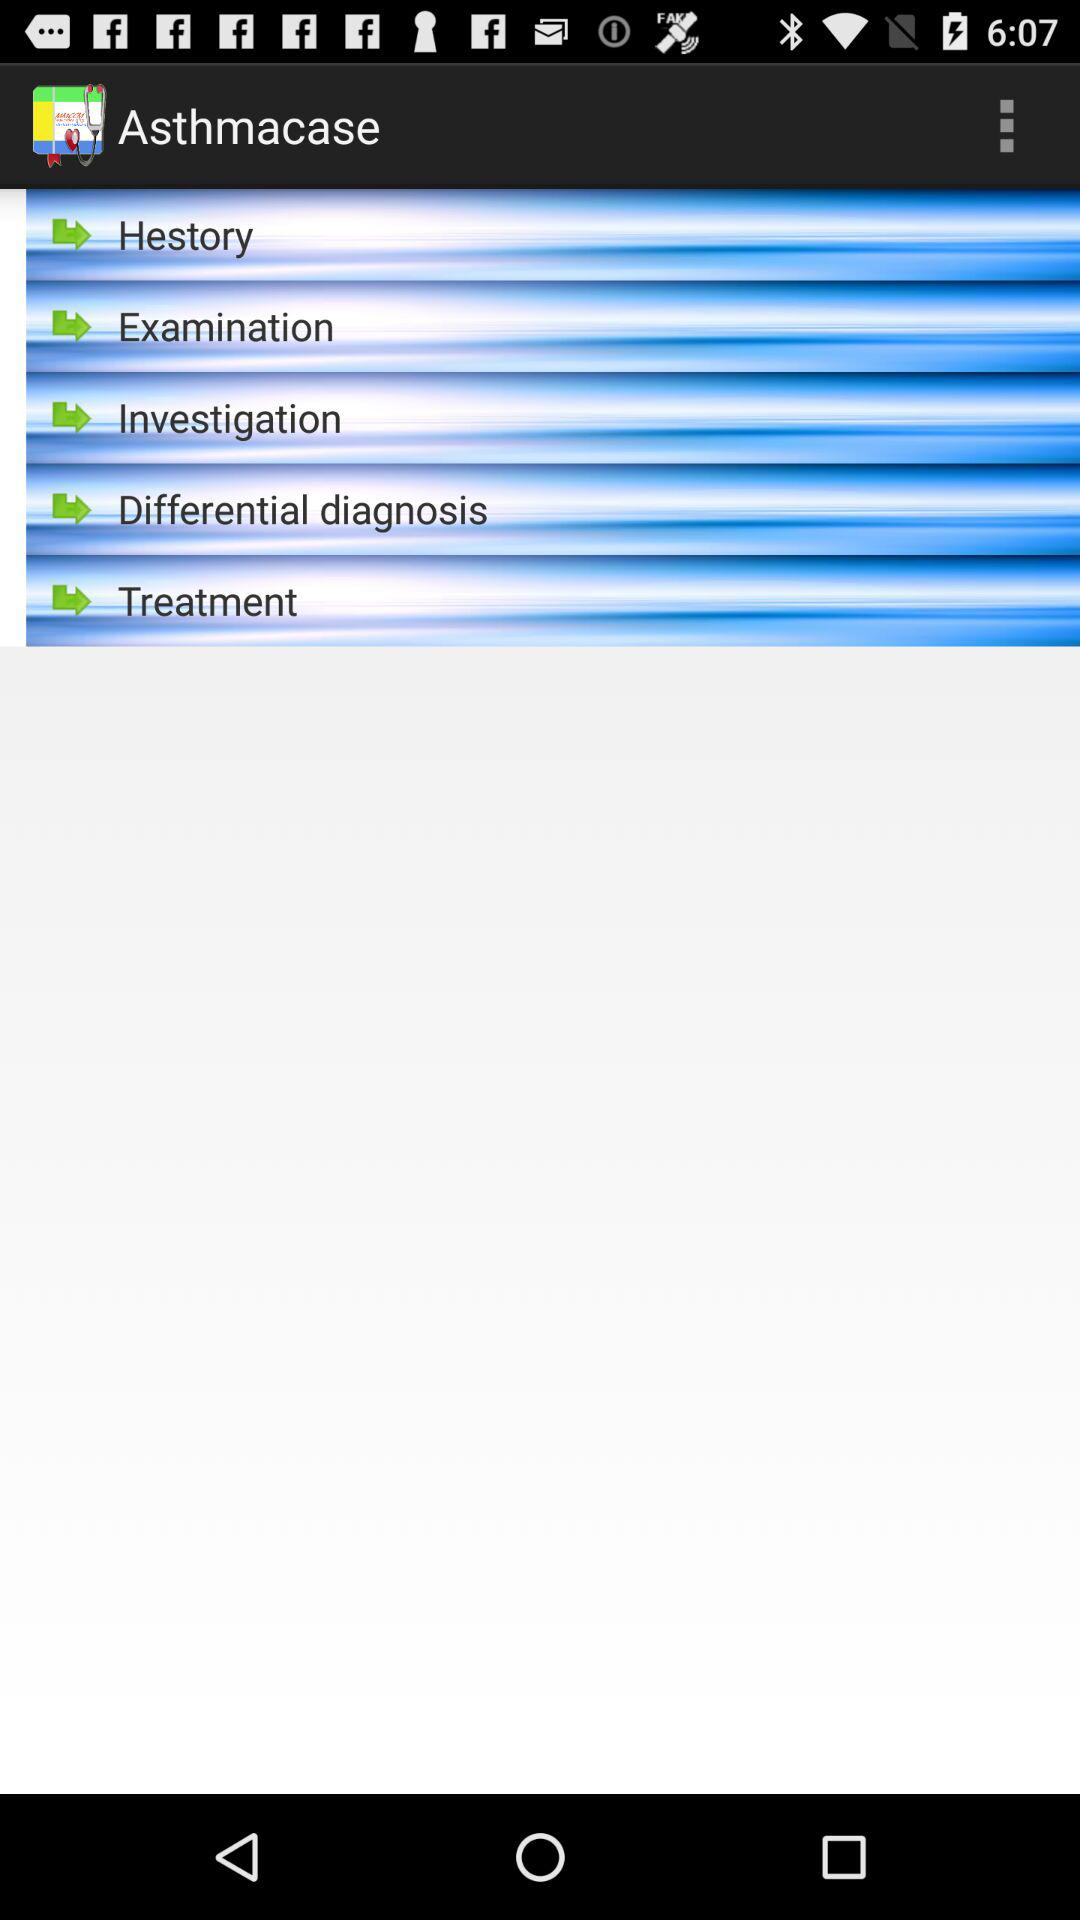What is the name of the application? The name of the application is "Asthmacase". 